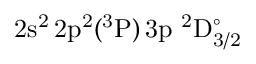<formula> <loc_0><loc_0><loc_500><loc_500>2 s ^ { 2 } \, 2 p ^ { 2 } ( ^ { 3 } P ) \, 3 p ^ { 2 } D _ { 3 / 2 } ^ { \circ }</formula> 